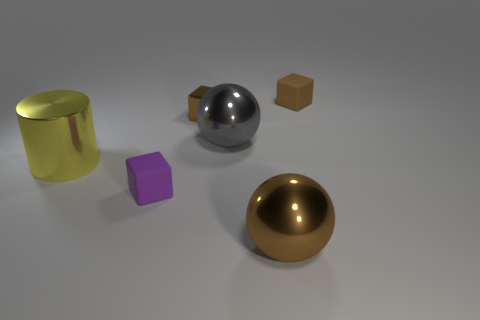Add 3 yellow shiny things. How many objects exist? 9 Subtract all tiny matte cubes. How many cubes are left? 1 Subtract all yellow spheres. How many purple blocks are left? 1 Subtract all big metallic spheres. Subtract all large things. How many objects are left? 1 Add 6 brown metallic cubes. How many brown metallic cubes are left? 7 Add 6 brown rubber spheres. How many brown rubber spheres exist? 6 Subtract all purple blocks. How many blocks are left? 2 Subtract 1 gray balls. How many objects are left? 5 Subtract all cylinders. How many objects are left? 5 Subtract 2 blocks. How many blocks are left? 1 